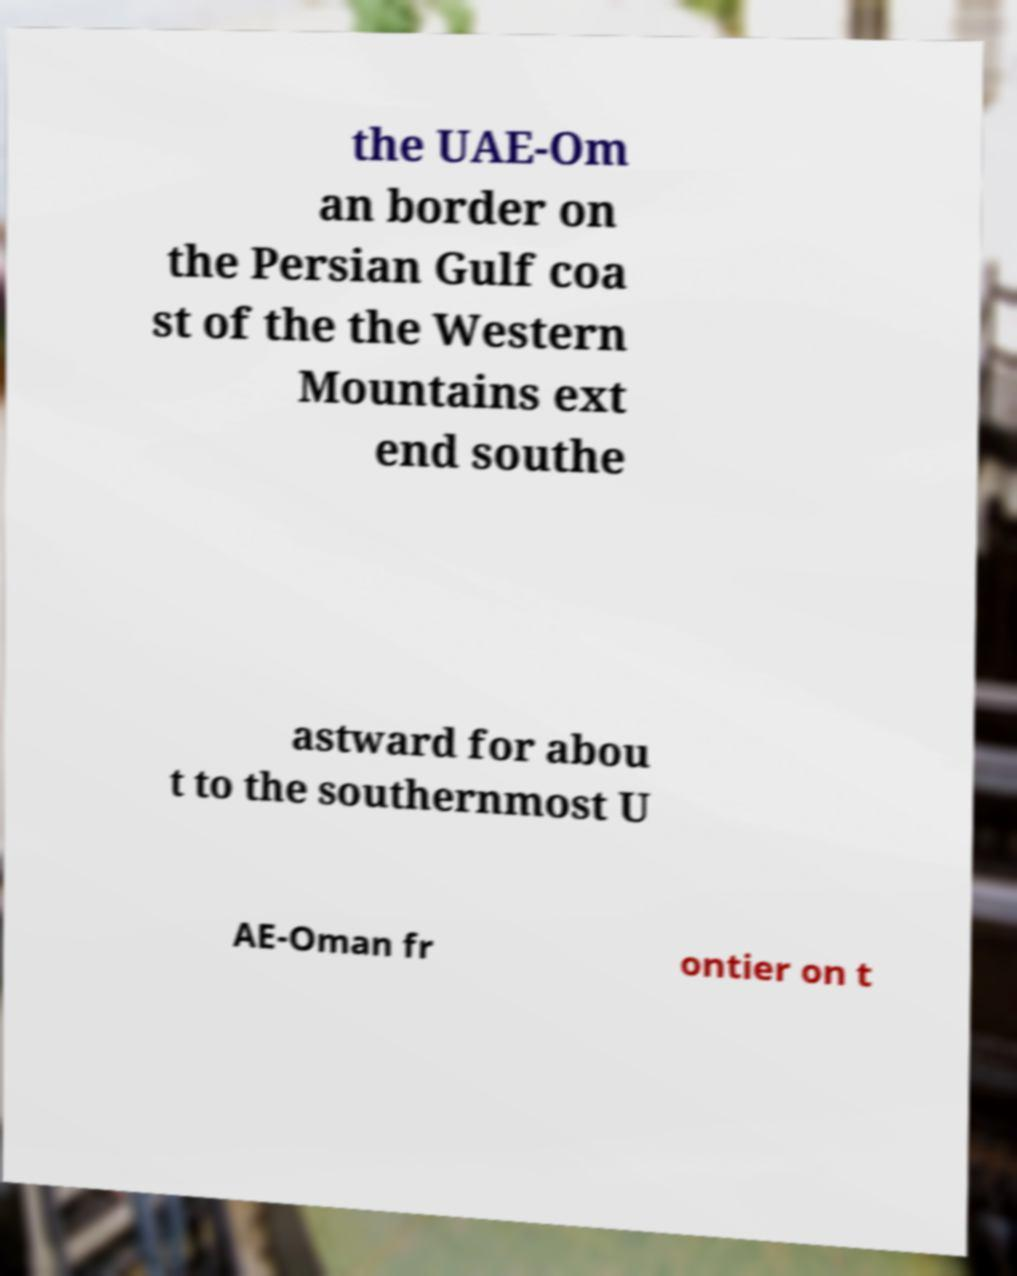Can you accurately transcribe the text from the provided image for me? the UAE-Om an border on the Persian Gulf coa st of the the Western Mountains ext end southe astward for abou t to the southernmost U AE-Oman fr ontier on t 